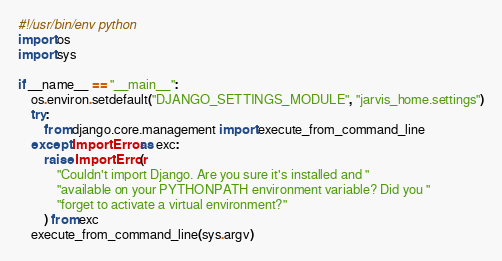Convert code to text. <code><loc_0><loc_0><loc_500><loc_500><_Python_>#!/usr/bin/env python
import os
import sys

if __name__ == "__main__":
    os.environ.setdefault("DJANGO_SETTINGS_MODULE", "jarvis_home.settings")
    try:
        from django.core.management import execute_from_command_line
    except ImportError as exc:
        raise ImportError(
            "Couldn't import Django. Are you sure it's installed and "
            "available on your PYTHONPATH environment variable? Did you "
            "forget to activate a virtual environment?"
        ) from exc
    execute_from_command_line(sys.argv)
</code> 